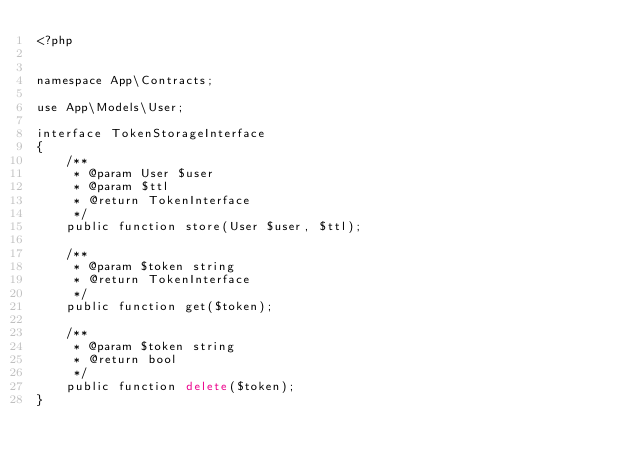Convert code to text. <code><loc_0><loc_0><loc_500><loc_500><_PHP_><?php


namespace App\Contracts;

use App\Models\User;

interface TokenStorageInterface
{
    /**
     * @param User $user
     * @param $ttl
     * @return TokenInterface
     */
    public function store(User $user, $ttl);

    /**
     * @param $token string
     * @return TokenInterface
     */
    public function get($token);

    /**
     * @param $token string
     * @return bool
     */
    public function delete($token);
}</code> 